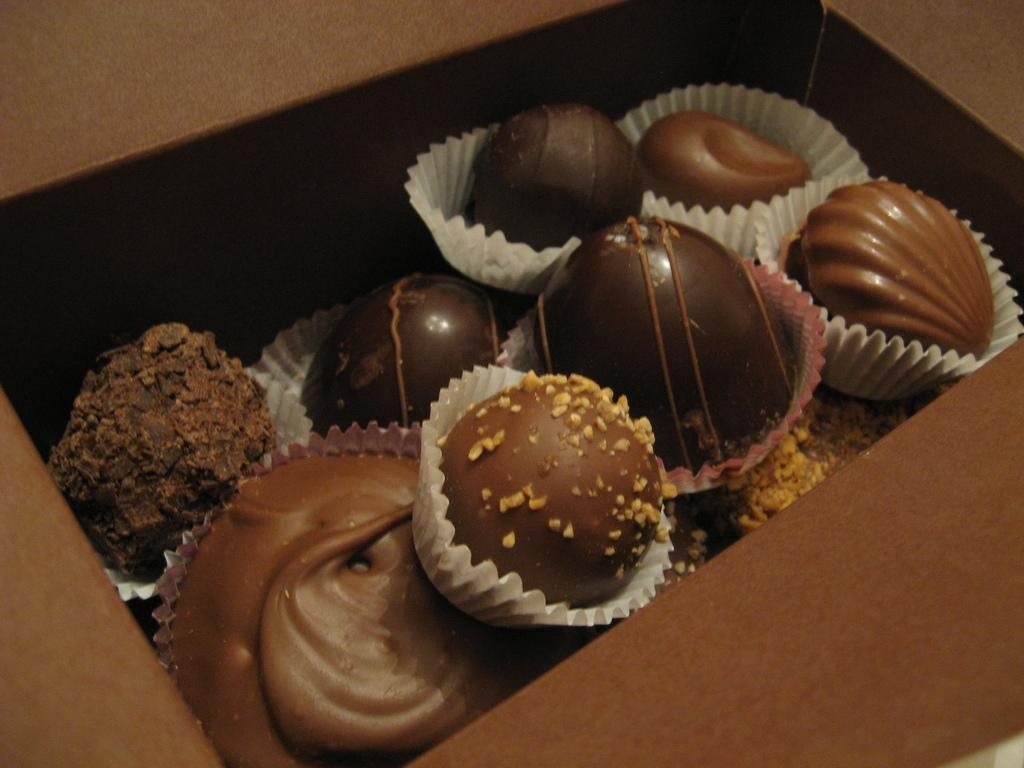What type of dessert is featured in the image? There are chocolate cakes in the image. How are the chocolate cakes packaged or presented? The chocolate cakes are in a brown color box. Can you see any ocean waves in the image? There is no reference to an ocean or waves in the image; it features chocolate cakes in a brown color box. 